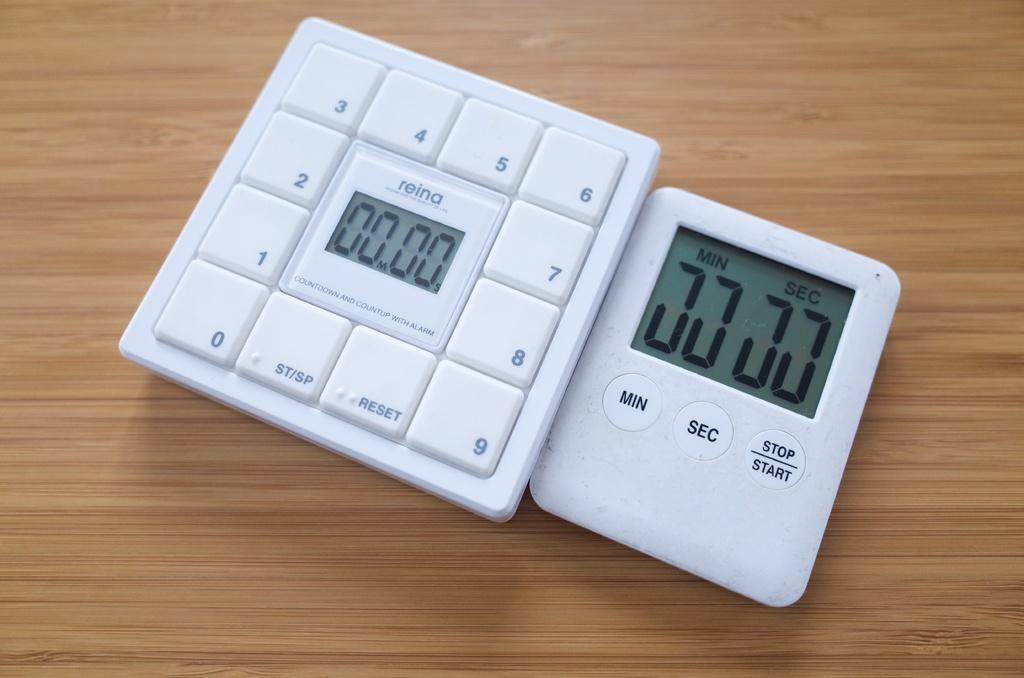What kinds of buttons are on the timer?
Keep it short and to the point. Min sec stop start. What does the middle button say on the left device?
Your answer should be very brief. Reina. 